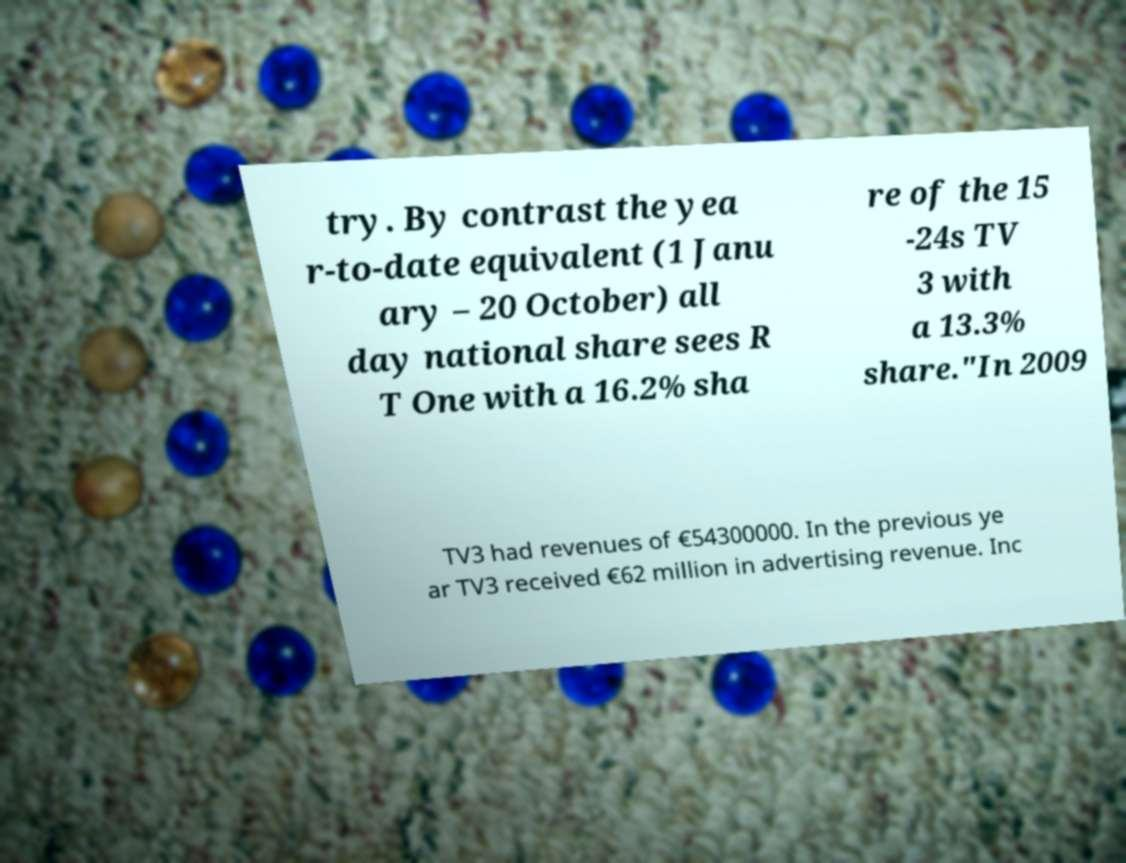Please identify and transcribe the text found in this image. try. By contrast the yea r-to-date equivalent (1 Janu ary – 20 October) all day national share sees R T One with a 16.2% sha re of the 15 -24s TV 3 with a 13.3% share."In 2009 TV3 had revenues of €54300000. In the previous ye ar TV3 received €62 million in advertising revenue. Inc 